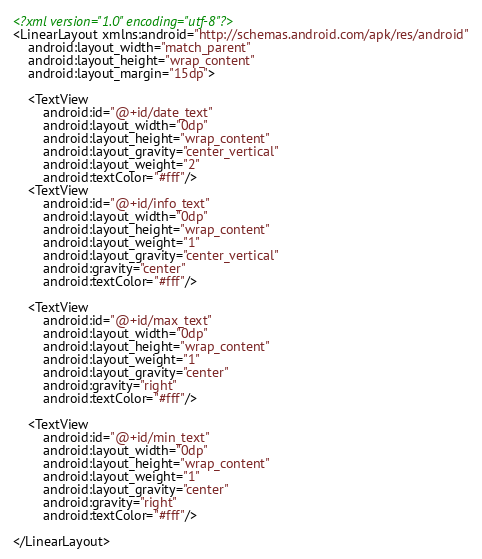Convert code to text. <code><loc_0><loc_0><loc_500><loc_500><_XML_><?xml version="1.0" encoding="utf-8"?>
<LinearLayout xmlns:android="http://schemas.android.com/apk/res/android"
    android:layout_width="match_parent"
    android:layout_height="wrap_content"
    android:layout_margin="15dp">

    <TextView
        android:id="@+id/date_text"
        android:layout_width="0dp"
        android:layout_height="wrap_content"
        android:layout_gravity="center_vertical"
        android:layout_weight="2"
        android:textColor="#fff"/>
    <TextView
        android:id="@+id/info_text"
        android:layout_width="0dp"
        android:layout_height="wrap_content"
        android:layout_weight="1"
        android:layout_gravity="center_vertical"
        android:gravity="center"
        android:textColor="#fff"/>

    <TextView
        android:id="@+id/max_text"
        android:layout_width="0dp"
        android:layout_height="wrap_content"
        android:layout_weight="1"
        android:layout_gravity="center"
        android:gravity="right"
        android:textColor="#fff"/>

    <TextView
        android:id="@+id/min_text"
        android:layout_width="0dp"
        android:layout_height="wrap_content"
        android:layout_weight="1"
        android:layout_gravity="center"
        android:gravity="right"
        android:textColor="#fff"/>

</LinearLayout></code> 